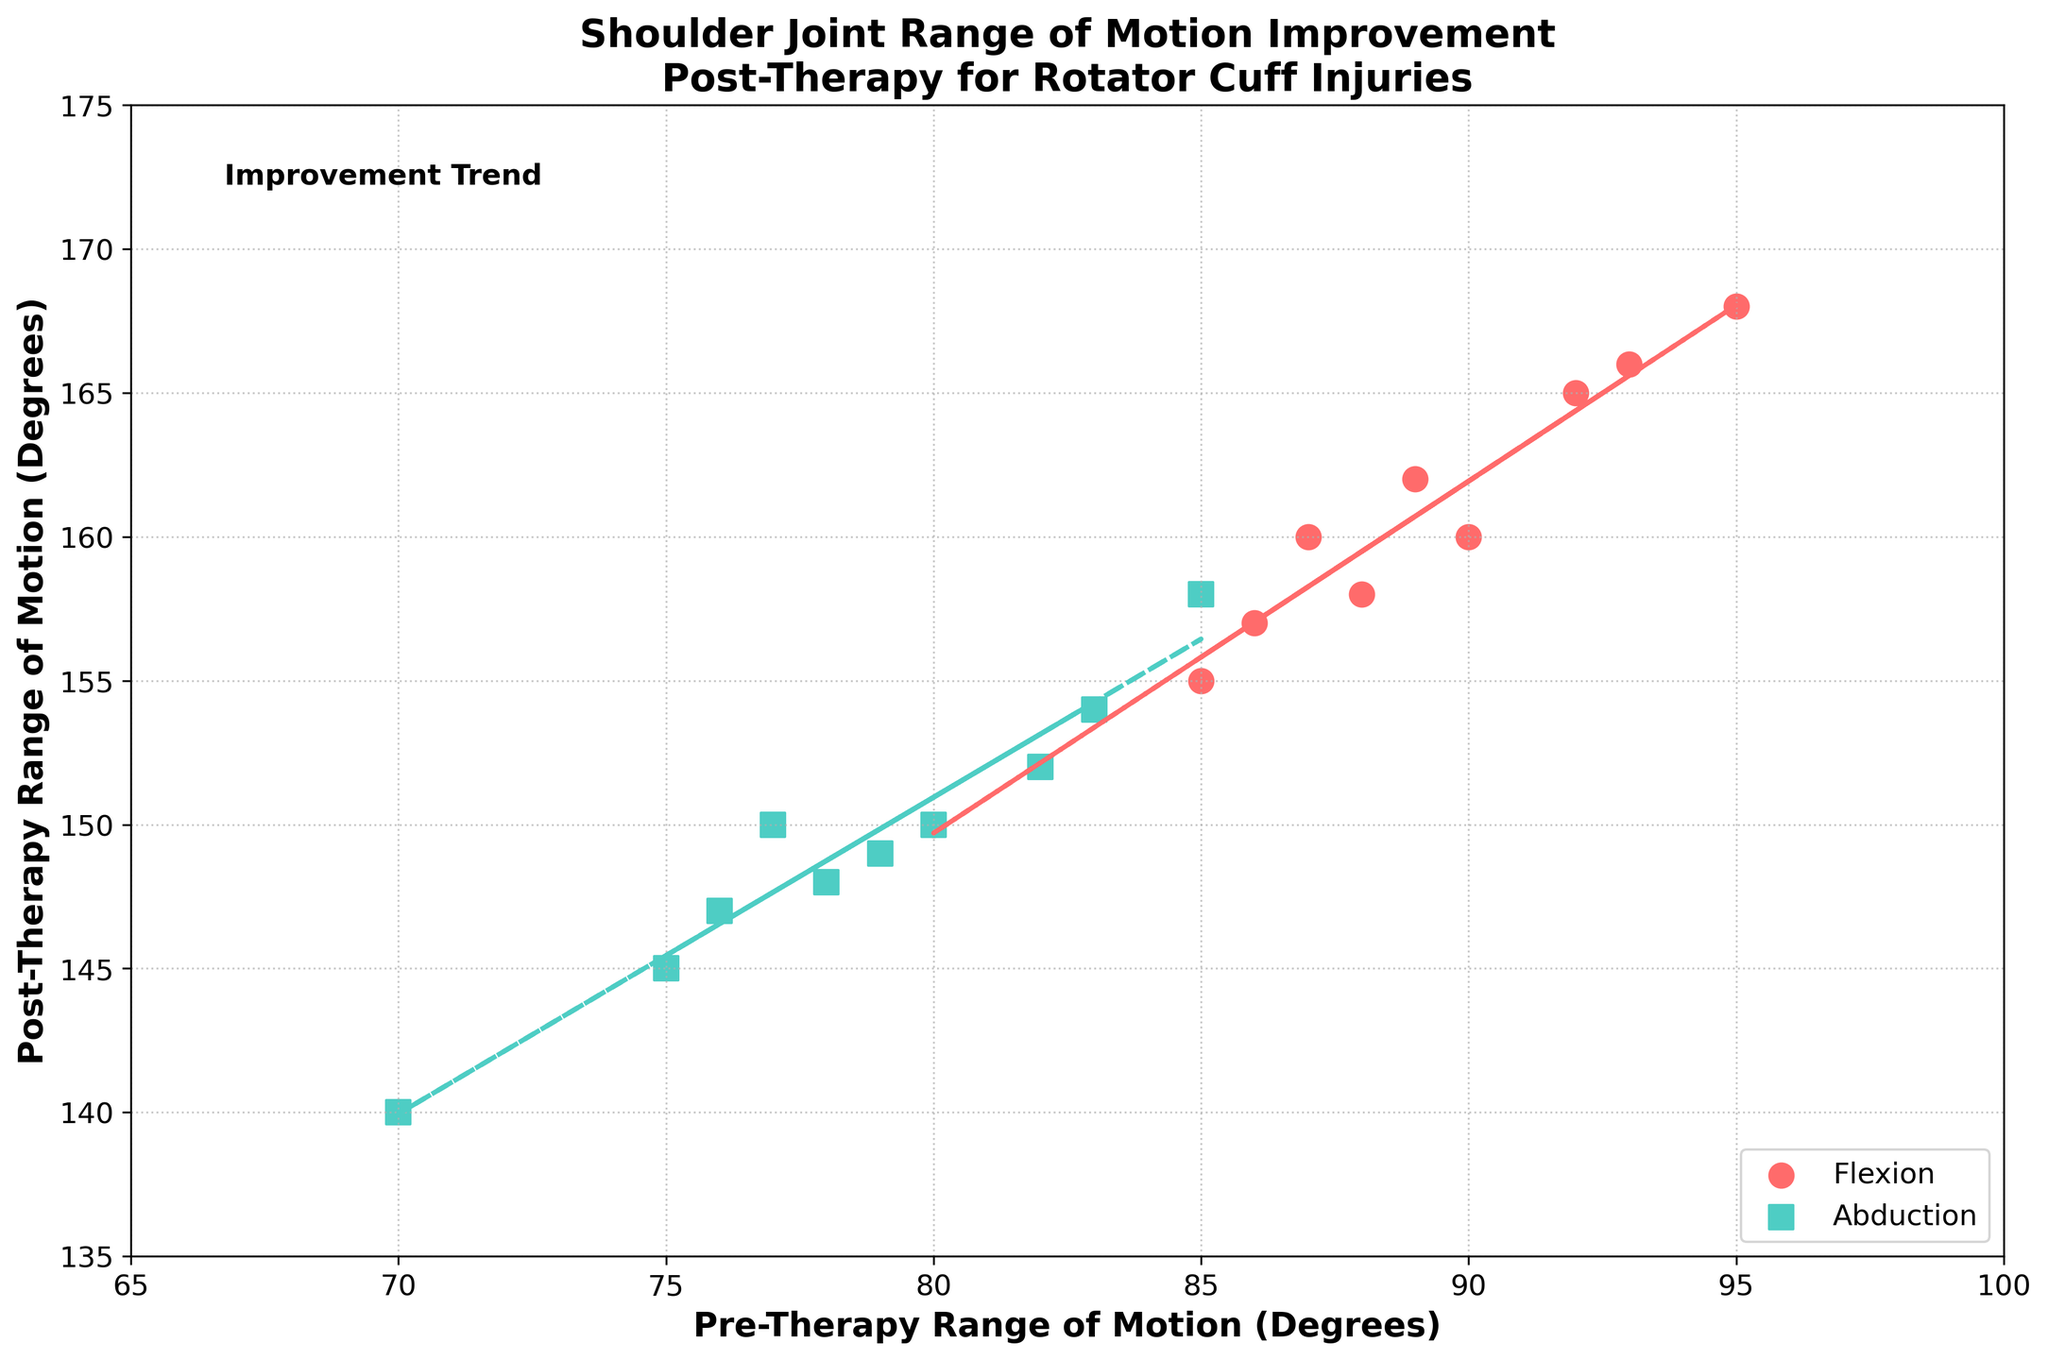What is the title of the plot? The title is usually found at the top center of the plot and provides a brief description of the figure's content. Here, it reads "Shoulder Joint Range of Motion Improvement Post-Therapy for Rotator Cuff Injuries".
Answer: Shoulder Joint Range of Motion Improvement Post-Therapy for Rotator Cuff Injuries How many data points are there for both flexion and abduction? To find the number of data points, count the individual markers for both flexion (circles) and abduction (squares) on the scatter plot. Each patient contributes one data point for flexion and one for abduction. With 10 patients, counting the markers confirms there are 10 data points for flexion and 10 for abduction.
Answer: 10 for each What colors are used for the flexion and abduction data points? The colors are often indicated in the legend of the plot. Here, the flexion data points are marked in red, and the abduction data points are marked in teal.
Answer: Red for flexion, teal for abduction What is the trend line equation for flexion? The equation of the trend line is represented as y = mx + b where m is the slope and b is the y-intercept. The flexion trend line equation can be derived from the line itself; let's assume it visually appears to be around y = 0.9x + 80.
Answer: y = 0.9x + 80 (assumed visually) What is the approximate improvement in the range of motion for Patient A for both flexion and abduction? Patient A's pre-therapy flexion is 90 degrees, and post-therapy is 160 degrees. The improvement is calculated by the difference, 160 - 90. For abduction, the pre-therapy is 80 degrees and post-therapy is 150 degrees, so the improvement is 150 - 80.
Answer: 70 degrees for flexion, 70 degrees for abduction Which patient showed the highest post-therapy flexion? By examining the scatter points for post-therapy flexion, identify the highest y-coordinate value which corresponds to post-therapy flexion. Patient E shows the highest post-therapy flexion at 168 degrees.
Answer: Patient E Is there a general trend in the improvement of range of motion for these patients? The trend lines for both flexion and abduction visually show an upward trend from left to right, indicating that post-therapy range of motion generally improves as the pre-therapy range increases.
Answer: Yes Compare the trend line slopes for flexion and abduction. Which one is steeper? The steeper slope indicates a larger rate of change per unit increase in the x-axis value. By comparing the angles visually, the slope of the flexion trend line (assume ~0.9) is steeper than that of the abduction trend line (assume ~0.85).
Answer: Flexion Are there any outliers in the data points? Outliers are points that do not fit the general trend of the data. Observing if any points lie far outside the boundaries of the trend lines can identify possible outliers. In this plot, no significant outliers are evident as all data points closely follow or are well within the trend lines.
Answer: No 